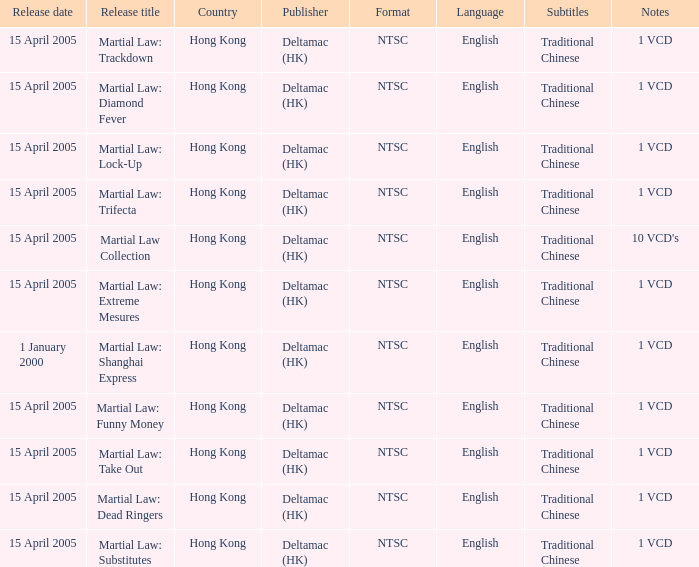What is the release date of Martial Law: Take Out? 15 April 2005. 